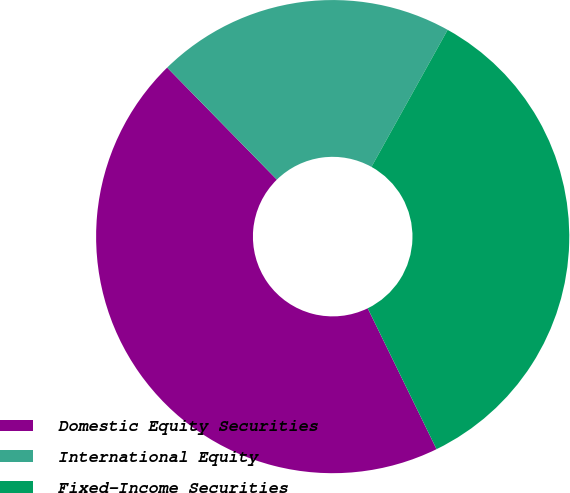Convert chart to OTSL. <chart><loc_0><loc_0><loc_500><loc_500><pie_chart><fcel>Domestic Equity Securities<fcel>International Equity<fcel>Fixed-Income Securities<nl><fcel>44.9%<fcel>20.41%<fcel>34.69%<nl></chart> 